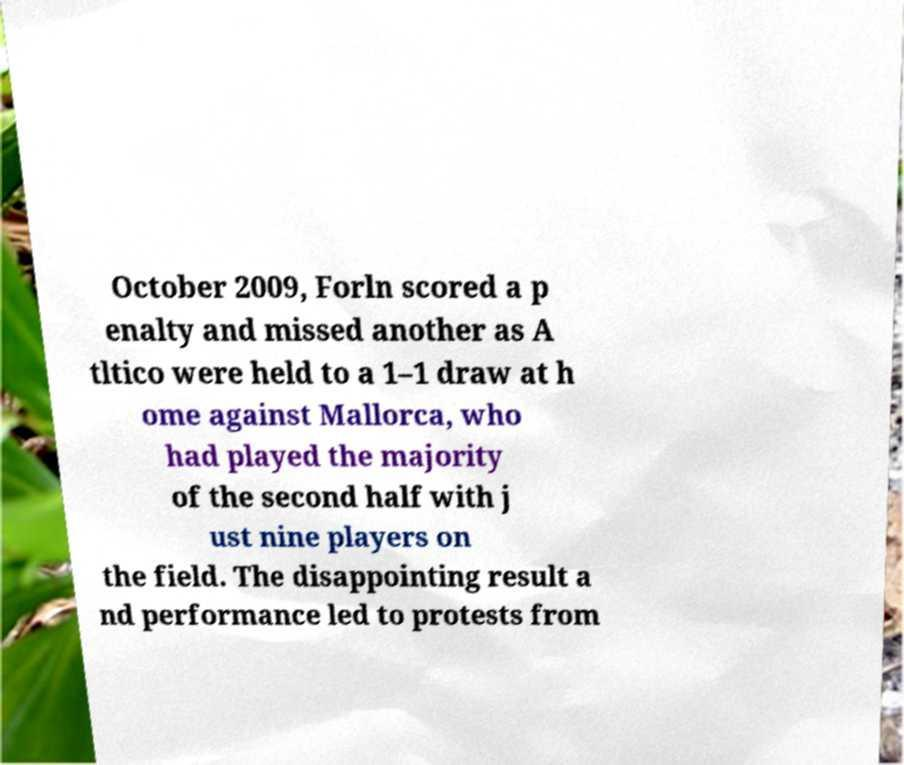Could you extract and type out the text from this image? October 2009, Forln scored a p enalty and missed another as A tltico were held to a 1–1 draw at h ome against Mallorca, who had played the majority of the second half with j ust nine players on the field. The disappointing result a nd performance led to protests from 